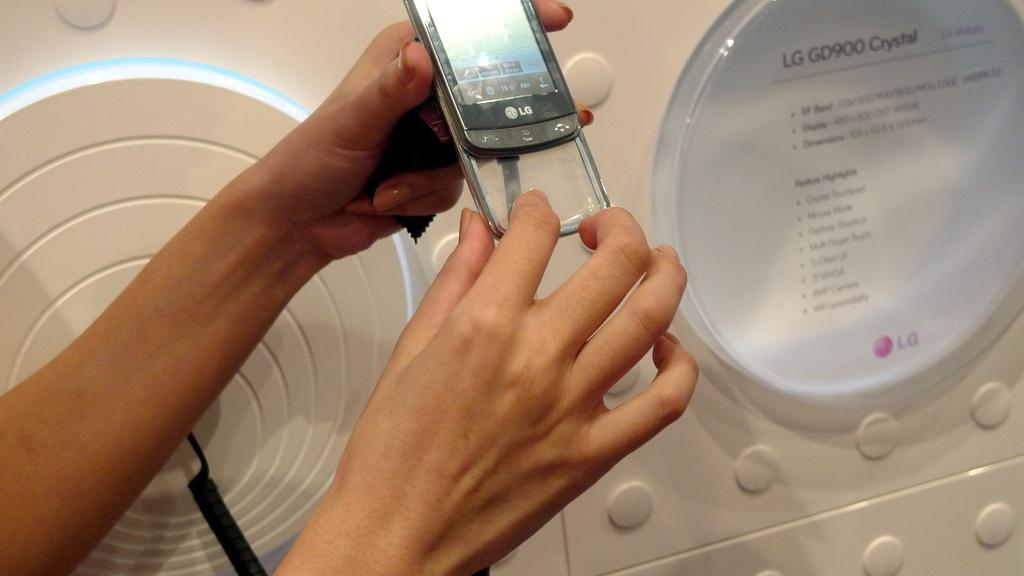<image>
Summarize the visual content of the image. a display of an LG GD900 Crystal cell phone 